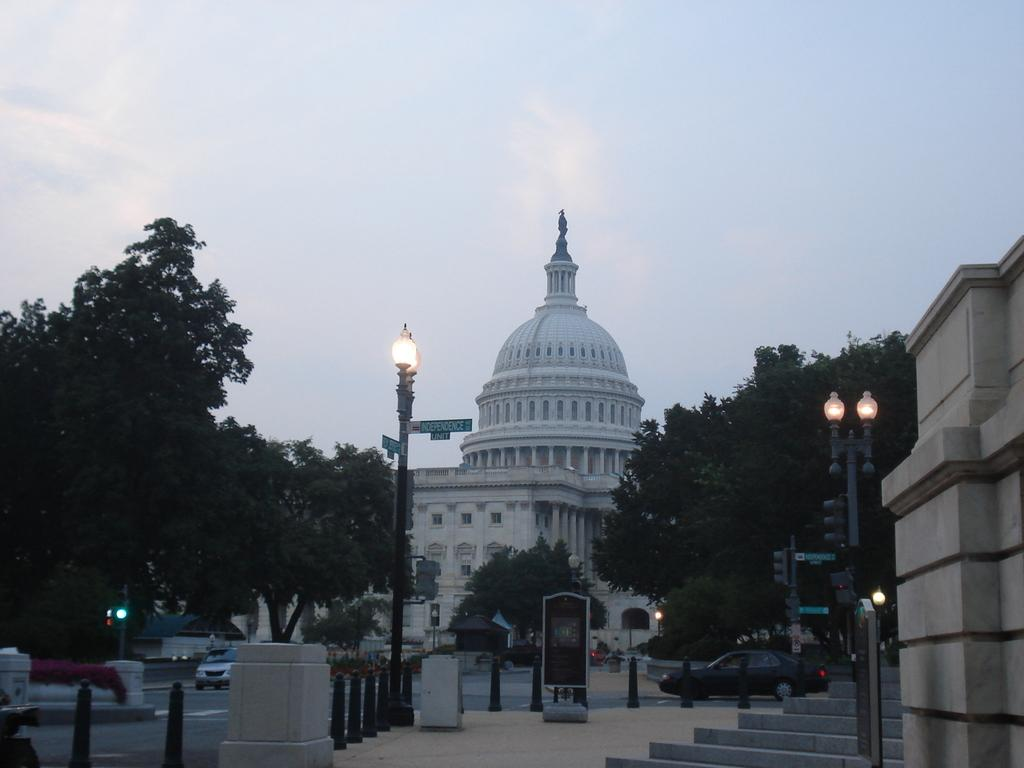What can be seen on the road in the image? There are vehicles on the road in the image. What structures are present along the road? There are light poles in the image. What type of vegetation is visible in the image? There are trees in the image. What are the small rods on the footpath used for? The small rods on the footpath are likely used for marking or delineating the path. How many buildings can be seen in the image? There is at least one building in the image. What is attached to the light poles in the image? There are boards on the poles in the image. What is visible in the sky in the image? Clouds are visible in the sky in the image. What color is the nerve that is visible in the image? There is no nerve visible in the image. How far away is the distance between the trees in the image? The provided facts do not give information about the distance between the trees, only that they are present in the image. 